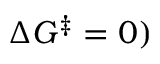<formula> <loc_0><loc_0><loc_500><loc_500>\Delta G ^ { \ddagger } = 0 )</formula> 